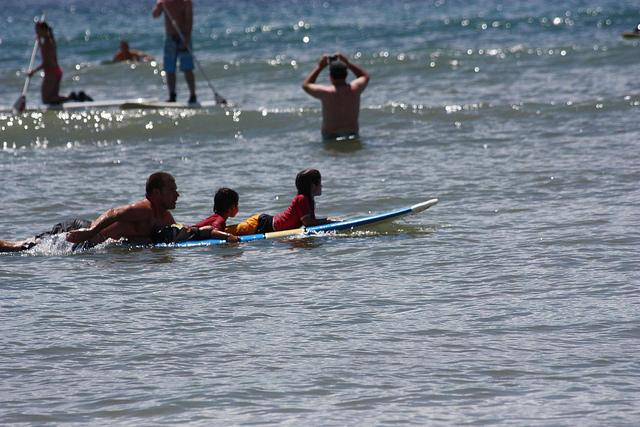What do the persons on boards here wish for? waves 